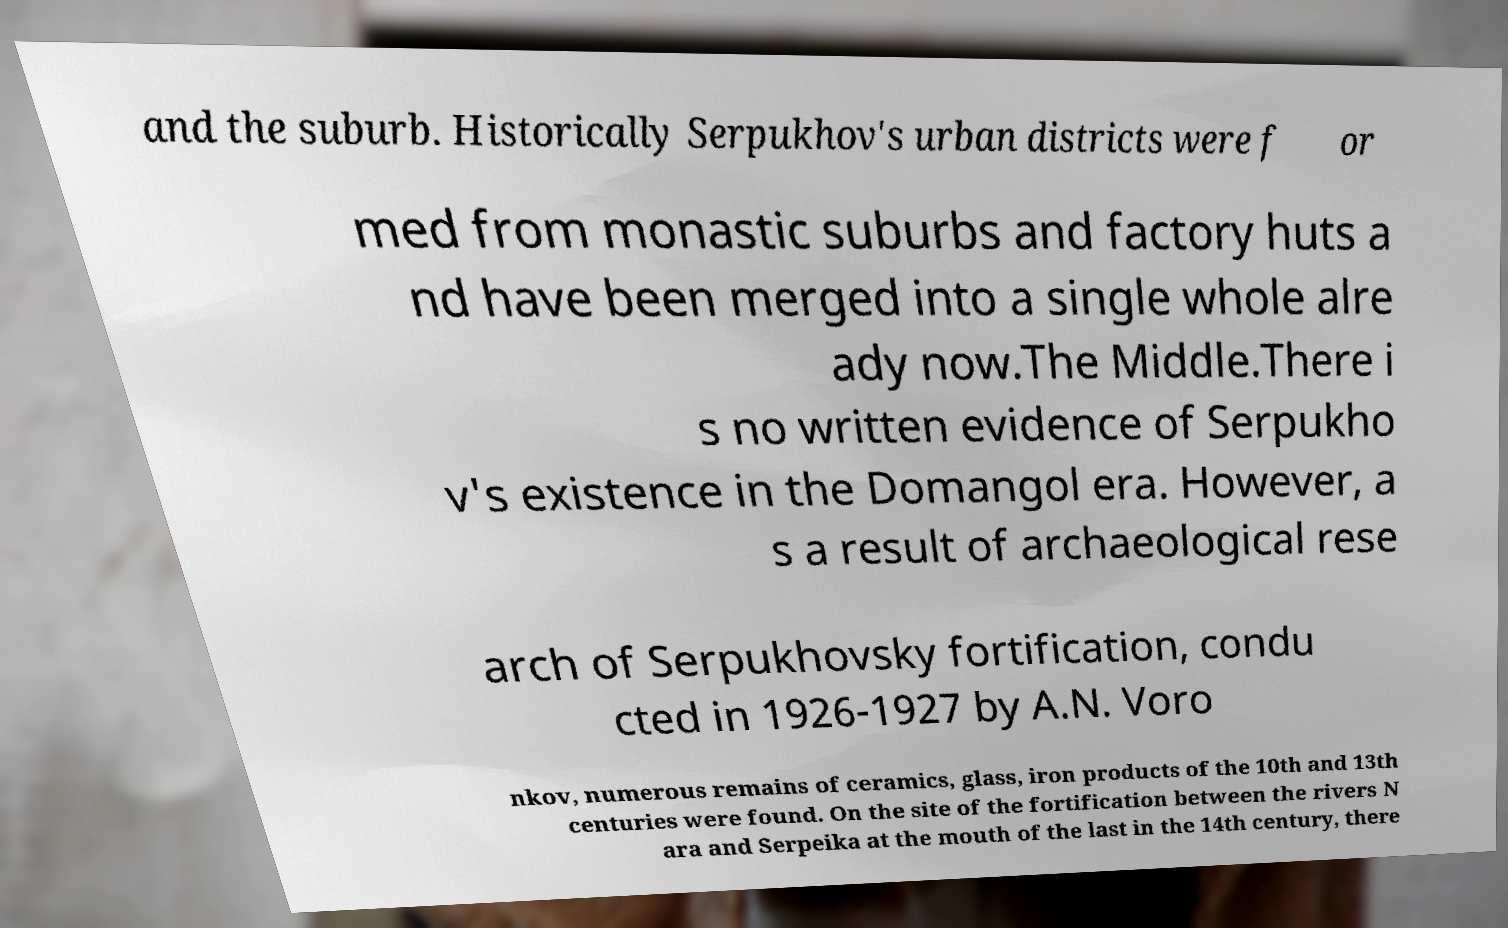Can you read and provide the text displayed in the image?This photo seems to have some interesting text. Can you extract and type it out for me? and the suburb. Historically Serpukhov's urban districts were f or med from monastic suburbs and factory huts a nd have been merged into a single whole alre ady now.The Middle.There i s no written evidence of Serpukho v's existence in the Domangol era. However, a s a result of archaeological rese arch of Serpukhovsky fortification, condu cted in 1926-1927 by A.N. Voro nkov, numerous remains of ceramics, glass, iron products of the 10th and 13th centuries were found. On the site of the fortification between the rivers N ara and Serpeika at the mouth of the last in the 14th century, there 